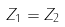Convert formula to latex. <formula><loc_0><loc_0><loc_500><loc_500>Z _ { 1 } = Z _ { 2 }</formula> 